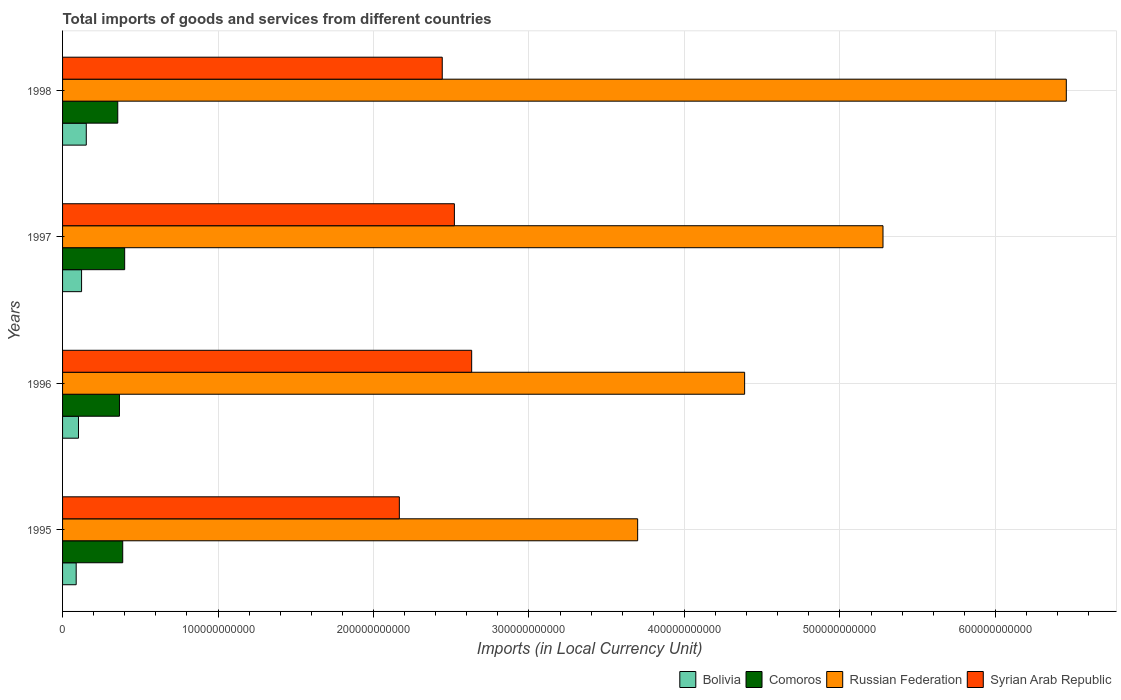Are the number of bars per tick equal to the number of legend labels?
Provide a short and direct response. Yes. How many bars are there on the 4th tick from the bottom?
Your answer should be very brief. 4. In how many cases, is the number of bars for a given year not equal to the number of legend labels?
Make the answer very short. 0. What is the Amount of goods and services imports in Russian Federation in 1995?
Offer a very short reply. 3.70e+11. Across all years, what is the maximum Amount of goods and services imports in Syrian Arab Republic?
Ensure brevity in your answer.  2.63e+11. Across all years, what is the minimum Amount of goods and services imports in Russian Federation?
Your answer should be compact. 3.70e+11. In which year was the Amount of goods and services imports in Comoros minimum?
Provide a short and direct response. 1998. What is the total Amount of goods and services imports in Russian Federation in the graph?
Your answer should be compact. 1.98e+12. What is the difference between the Amount of goods and services imports in Bolivia in 1995 and that in 1996?
Make the answer very short. -1.47e+09. What is the difference between the Amount of goods and services imports in Syrian Arab Republic in 1996 and the Amount of goods and services imports in Russian Federation in 1995?
Your answer should be very brief. -1.07e+11. What is the average Amount of goods and services imports in Russian Federation per year?
Make the answer very short. 4.95e+11. In the year 1998, what is the difference between the Amount of goods and services imports in Bolivia and Amount of goods and services imports in Syrian Arab Republic?
Your answer should be compact. -2.29e+11. In how many years, is the Amount of goods and services imports in Bolivia greater than 300000000000 LCU?
Your response must be concise. 0. What is the ratio of the Amount of goods and services imports in Syrian Arab Republic in 1995 to that in 1997?
Give a very brief answer. 0.86. Is the Amount of goods and services imports in Comoros in 1996 less than that in 1998?
Your response must be concise. No. What is the difference between the highest and the second highest Amount of goods and services imports in Russian Federation?
Provide a short and direct response. 1.18e+11. What is the difference between the highest and the lowest Amount of goods and services imports in Syrian Arab Republic?
Provide a succinct answer. 4.65e+1. What does the 2nd bar from the top in 1997 represents?
Your answer should be compact. Russian Federation. What does the 4th bar from the bottom in 1995 represents?
Offer a very short reply. Syrian Arab Republic. Is it the case that in every year, the sum of the Amount of goods and services imports in Russian Federation and Amount of goods and services imports in Comoros is greater than the Amount of goods and services imports in Bolivia?
Ensure brevity in your answer.  Yes. Are all the bars in the graph horizontal?
Provide a succinct answer. Yes. How many years are there in the graph?
Provide a succinct answer. 4. What is the difference between two consecutive major ticks on the X-axis?
Your answer should be compact. 1.00e+11. Are the values on the major ticks of X-axis written in scientific E-notation?
Provide a short and direct response. No. Where does the legend appear in the graph?
Offer a very short reply. Bottom right. How are the legend labels stacked?
Ensure brevity in your answer.  Horizontal. What is the title of the graph?
Give a very brief answer. Total imports of goods and services from different countries. Does "Kyrgyz Republic" appear as one of the legend labels in the graph?
Make the answer very short. No. What is the label or title of the X-axis?
Provide a succinct answer. Imports (in Local Currency Unit). What is the Imports (in Local Currency Unit) of Bolivia in 1995?
Give a very brief answer. 8.76e+09. What is the Imports (in Local Currency Unit) in Comoros in 1995?
Give a very brief answer. 3.87e+1. What is the Imports (in Local Currency Unit) in Russian Federation in 1995?
Your answer should be very brief. 3.70e+11. What is the Imports (in Local Currency Unit) in Syrian Arab Republic in 1995?
Offer a terse response. 2.17e+11. What is the Imports (in Local Currency Unit) of Bolivia in 1996?
Offer a terse response. 1.02e+1. What is the Imports (in Local Currency Unit) of Comoros in 1996?
Offer a very short reply. 3.66e+1. What is the Imports (in Local Currency Unit) of Russian Federation in 1996?
Make the answer very short. 4.39e+11. What is the Imports (in Local Currency Unit) of Syrian Arab Republic in 1996?
Ensure brevity in your answer.  2.63e+11. What is the Imports (in Local Currency Unit) of Bolivia in 1997?
Your answer should be compact. 1.22e+1. What is the Imports (in Local Currency Unit) of Comoros in 1997?
Offer a terse response. 3.99e+1. What is the Imports (in Local Currency Unit) of Russian Federation in 1997?
Ensure brevity in your answer.  5.28e+11. What is the Imports (in Local Currency Unit) in Syrian Arab Republic in 1997?
Your answer should be compact. 2.52e+11. What is the Imports (in Local Currency Unit) of Bolivia in 1998?
Make the answer very short. 1.53e+1. What is the Imports (in Local Currency Unit) in Comoros in 1998?
Your response must be concise. 3.55e+1. What is the Imports (in Local Currency Unit) of Russian Federation in 1998?
Ensure brevity in your answer.  6.46e+11. What is the Imports (in Local Currency Unit) in Syrian Arab Republic in 1998?
Give a very brief answer. 2.44e+11. Across all years, what is the maximum Imports (in Local Currency Unit) in Bolivia?
Make the answer very short. 1.53e+1. Across all years, what is the maximum Imports (in Local Currency Unit) of Comoros?
Give a very brief answer. 3.99e+1. Across all years, what is the maximum Imports (in Local Currency Unit) in Russian Federation?
Your response must be concise. 6.46e+11. Across all years, what is the maximum Imports (in Local Currency Unit) in Syrian Arab Republic?
Give a very brief answer. 2.63e+11. Across all years, what is the minimum Imports (in Local Currency Unit) of Bolivia?
Your answer should be very brief. 8.76e+09. Across all years, what is the minimum Imports (in Local Currency Unit) in Comoros?
Your answer should be very brief. 3.55e+1. Across all years, what is the minimum Imports (in Local Currency Unit) of Russian Federation?
Your response must be concise. 3.70e+11. Across all years, what is the minimum Imports (in Local Currency Unit) in Syrian Arab Republic?
Make the answer very short. 2.17e+11. What is the total Imports (in Local Currency Unit) in Bolivia in the graph?
Provide a short and direct response. 4.65e+1. What is the total Imports (in Local Currency Unit) in Comoros in the graph?
Provide a succinct answer. 1.51e+11. What is the total Imports (in Local Currency Unit) of Russian Federation in the graph?
Ensure brevity in your answer.  1.98e+12. What is the total Imports (in Local Currency Unit) of Syrian Arab Republic in the graph?
Give a very brief answer. 9.76e+11. What is the difference between the Imports (in Local Currency Unit) in Bolivia in 1995 and that in 1996?
Ensure brevity in your answer.  -1.47e+09. What is the difference between the Imports (in Local Currency Unit) in Comoros in 1995 and that in 1996?
Offer a terse response. 2.10e+09. What is the difference between the Imports (in Local Currency Unit) of Russian Federation in 1995 and that in 1996?
Ensure brevity in your answer.  -6.88e+1. What is the difference between the Imports (in Local Currency Unit) of Syrian Arab Republic in 1995 and that in 1996?
Provide a short and direct response. -4.65e+1. What is the difference between the Imports (in Local Currency Unit) of Bolivia in 1995 and that in 1997?
Offer a terse response. -3.46e+09. What is the difference between the Imports (in Local Currency Unit) of Comoros in 1995 and that in 1997?
Your response must be concise. -1.26e+09. What is the difference between the Imports (in Local Currency Unit) of Russian Federation in 1995 and that in 1997?
Keep it short and to the point. -1.58e+11. What is the difference between the Imports (in Local Currency Unit) in Syrian Arab Republic in 1995 and that in 1997?
Your answer should be very brief. -3.54e+1. What is the difference between the Imports (in Local Currency Unit) in Bolivia in 1995 and that in 1998?
Keep it short and to the point. -6.49e+09. What is the difference between the Imports (in Local Currency Unit) in Comoros in 1995 and that in 1998?
Offer a terse response. 3.18e+09. What is the difference between the Imports (in Local Currency Unit) of Russian Federation in 1995 and that in 1998?
Offer a terse response. -2.76e+11. What is the difference between the Imports (in Local Currency Unit) of Syrian Arab Republic in 1995 and that in 1998?
Offer a terse response. -2.76e+1. What is the difference between the Imports (in Local Currency Unit) in Bolivia in 1996 and that in 1997?
Keep it short and to the point. -1.99e+09. What is the difference between the Imports (in Local Currency Unit) of Comoros in 1996 and that in 1997?
Keep it short and to the point. -3.35e+09. What is the difference between the Imports (in Local Currency Unit) of Russian Federation in 1996 and that in 1997?
Your answer should be compact. -8.90e+1. What is the difference between the Imports (in Local Currency Unit) in Syrian Arab Republic in 1996 and that in 1997?
Ensure brevity in your answer.  1.11e+1. What is the difference between the Imports (in Local Currency Unit) in Bolivia in 1996 and that in 1998?
Your answer should be compact. -5.02e+09. What is the difference between the Imports (in Local Currency Unit) of Comoros in 1996 and that in 1998?
Your answer should be very brief. 1.09e+09. What is the difference between the Imports (in Local Currency Unit) of Russian Federation in 1996 and that in 1998?
Ensure brevity in your answer.  -2.07e+11. What is the difference between the Imports (in Local Currency Unit) in Syrian Arab Republic in 1996 and that in 1998?
Your answer should be very brief. 1.89e+1. What is the difference between the Imports (in Local Currency Unit) of Bolivia in 1997 and that in 1998?
Offer a very short reply. -3.03e+09. What is the difference between the Imports (in Local Currency Unit) in Comoros in 1997 and that in 1998?
Your answer should be very brief. 4.44e+09. What is the difference between the Imports (in Local Currency Unit) in Russian Federation in 1997 and that in 1998?
Your response must be concise. -1.18e+11. What is the difference between the Imports (in Local Currency Unit) in Syrian Arab Republic in 1997 and that in 1998?
Give a very brief answer. 7.81e+09. What is the difference between the Imports (in Local Currency Unit) of Bolivia in 1995 and the Imports (in Local Currency Unit) of Comoros in 1996?
Give a very brief answer. -2.78e+1. What is the difference between the Imports (in Local Currency Unit) of Bolivia in 1995 and the Imports (in Local Currency Unit) of Russian Federation in 1996?
Provide a succinct answer. -4.30e+11. What is the difference between the Imports (in Local Currency Unit) of Bolivia in 1995 and the Imports (in Local Currency Unit) of Syrian Arab Republic in 1996?
Your answer should be compact. -2.54e+11. What is the difference between the Imports (in Local Currency Unit) of Comoros in 1995 and the Imports (in Local Currency Unit) of Russian Federation in 1996?
Ensure brevity in your answer.  -4.00e+11. What is the difference between the Imports (in Local Currency Unit) of Comoros in 1995 and the Imports (in Local Currency Unit) of Syrian Arab Republic in 1996?
Provide a succinct answer. -2.24e+11. What is the difference between the Imports (in Local Currency Unit) in Russian Federation in 1995 and the Imports (in Local Currency Unit) in Syrian Arab Republic in 1996?
Offer a very short reply. 1.07e+11. What is the difference between the Imports (in Local Currency Unit) of Bolivia in 1995 and the Imports (in Local Currency Unit) of Comoros in 1997?
Offer a very short reply. -3.12e+1. What is the difference between the Imports (in Local Currency Unit) of Bolivia in 1995 and the Imports (in Local Currency Unit) of Russian Federation in 1997?
Offer a terse response. -5.19e+11. What is the difference between the Imports (in Local Currency Unit) in Bolivia in 1995 and the Imports (in Local Currency Unit) in Syrian Arab Republic in 1997?
Offer a terse response. -2.43e+11. What is the difference between the Imports (in Local Currency Unit) in Comoros in 1995 and the Imports (in Local Currency Unit) in Russian Federation in 1997?
Give a very brief answer. -4.89e+11. What is the difference between the Imports (in Local Currency Unit) in Comoros in 1995 and the Imports (in Local Currency Unit) in Syrian Arab Republic in 1997?
Your response must be concise. -2.13e+11. What is the difference between the Imports (in Local Currency Unit) of Russian Federation in 1995 and the Imports (in Local Currency Unit) of Syrian Arab Republic in 1997?
Keep it short and to the point. 1.18e+11. What is the difference between the Imports (in Local Currency Unit) of Bolivia in 1995 and the Imports (in Local Currency Unit) of Comoros in 1998?
Give a very brief answer. -2.67e+1. What is the difference between the Imports (in Local Currency Unit) in Bolivia in 1995 and the Imports (in Local Currency Unit) in Russian Federation in 1998?
Provide a short and direct response. -6.37e+11. What is the difference between the Imports (in Local Currency Unit) in Bolivia in 1995 and the Imports (in Local Currency Unit) in Syrian Arab Republic in 1998?
Your answer should be compact. -2.35e+11. What is the difference between the Imports (in Local Currency Unit) of Comoros in 1995 and the Imports (in Local Currency Unit) of Russian Federation in 1998?
Give a very brief answer. -6.07e+11. What is the difference between the Imports (in Local Currency Unit) in Comoros in 1995 and the Imports (in Local Currency Unit) in Syrian Arab Republic in 1998?
Your answer should be very brief. -2.06e+11. What is the difference between the Imports (in Local Currency Unit) in Russian Federation in 1995 and the Imports (in Local Currency Unit) in Syrian Arab Republic in 1998?
Ensure brevity in your answer.  1.26e+11. What is the difference between the Imports (in Local Currency Unit) of Bolivia in 1996 and the Imports (in Local Currency Unit) of Comoros in 1997?
Provide a succinct answer. -2.97e+1. What is the difference between the Imports (in Local Currency Unit) in Bolivia in 1996 and the Imports (in Local Currency Unit) in Russian Federation in 1997?
Your answer should be compact. -5.17e+11. What is the difference between the Imports (in Local Currency Unit) of Bolivia in 1996 and the Imports (in Local Currency Unit) of Syrian Arab Republic in 1997?
Your response must be concise. -2.42e+11. What is the difference between the Imports (in Local Currency Unit) of Comoros in 1996 and the Imports (in Local Currency Unit) of Russian Federation in 1997?
Provide a succinct answer. -4.91e+11. What is the difference between the Imports (in Local Currency Unit) in Comoros in 1996 and the Imports (in Local Currency Unit) in Syrian Arab Republic in 1997?
Give a very brief answer. -2.15e+11. What is the difference between the Imports (in Local Currency Unit) of Russian Federation in 1996 and the Imports (in Local Currency Unit) of Syrian Arab Republic in 1997?
Offer a very short reply. 1.87e+11. What is the difference between the Imports (in Local Currency Unit) of Bolivia in 1996 and the Imports (in Local Currency Unit) of Comoros in 1998?
Offer a terse response. -2.53e+1. What is the difference between the Imports (in Local Currency Unit) in Bolivia in 1996 and the Imports (in Local Currency Unit) in Russian Federation in 1998?
Ensure brevity in your answer.  -6.35e+11. What is the difference between the Imports (in Local Currency Unit) of Bolivia in 1996 and the Imports (in Local Currency Unit) of Syrian Arab Republic in 1998?
Offer a terse response. -2.34e+11. What is the difference between the Imports (in Local Currency Unit) in Comoros in 1996 and the Imports (in Local Currency Unit) in Russian Federation in 1998?
Provide a succinct answer. -6.09e+11. What is the difference between the Imports (in Local Currency Unit) in Comoros in 1996 and the Imports (in Local Currency Unit) in Syrian Arab Republic in 1998?
Offer a very short reply. -2.08e+11. What is the difference between the Imports (in Local Currency Unit) in Russian Federation in 1996 and the Imports (in Local Currency Unit) in Syrian Arab Republic in 1998?
Provide a short and direct response. 1.94e+11. What is the difference between the Imports (in Local Currency Unit) of Bolivia in 1997 and the Imports (in Local Currency Unit) of Comoros in 1998?
Provide a succinct answer. -2.33e+1. What is the difference between the Imports (in Local Currency Unit) in Bolivia in 1997 and the Imports (in Local Currency Unit) in Russian Federation in 1998?
Offer a very short reply. -6.33e+11. What is the difference between the Imports (in Local Currency Unit) in Bolivia in 1997 and the Imports (in Local Currency Unit) in Syrian Arab Republic in 1998?
Provide a short and direct response. -2.32e+11. What is the difference between the Imports (in Local Currency Unit) of Comoros in 1997 and the Imports (in Local Currency Unit) of Russian Federation in 1998?
Keep it short and to the point. -6.06e+11. What is the difference between the Imports (in Local Currency Unit) of Comoros in 1997 and the Imports (in Local Currency Unit) of Syrian Arab Republic in 1998?
Your response must be concise. -2.04e+11. What is the difference between the Imports (in Local Currency Unit) in Russian Federation in 1997 and the Imports (in Local Currency Unit) in Syrian Arab Republic in 1998?
Offer a very short reply. 2.83e+11. What is the average Imports (in Local Currency Unit) of Bolivia per year?
Offer a very short reply. 1.16e+1. What is the average Imports (in Local Currency Unit) in Comoros per year?
Keep it short and to the point. 3.77e+1. What is the average Imports (in Local Currency Unit) of Russian Federation per year?
Your answer should be compact. 4.95e+11. What is the average Imports (in Local Currency Unit) in Syrian Arab Republic per year?
Provide a short and direct response. 2.44e+11. In the year 1995, what is the difference between the Imports (in Local Currency Unit) of Bolivia and Imports (in Local Currency Unit) of Comoros?
Give a very brief answer. -2.99e+1. In the year 1995, what is the difference between the Imports (in Local Currency Unit) in Bolivia and Imports (in Local Currency Unit) in Russian Federation?
Give a very brief answer. -3.61e+11. In the year 1995, what is the difference between the Imports (in Local Currency Unit) in Bolivia and Imports (in Local Currency Unit) in Syrian Arab Republic?
Your answer should be very brief. -2.08e+11. In the year 1995, what is the difference between the Imports (in Local Currency Unit) in Comoros and Imports (in Local Currency Unit) in Russian Federation?
Your response must be concise. -3.31e+11. In the year 1995, what is the difference between the Imports (in Local Currency Unit) of Comoros and Imports (in Local Currency Unit) of Syrian Arab Republic?
Make the answer very short. -1.78e+11. In the year 1995, what is the difference between the Imports (in Local Currency Unit) of Russian Federation and Imports (in Local Currency Unit) of Syrian Arab Republic?
Offer a very short reply. 1.53e+11. In the year 1996, what is the difference between the Imports (in Local Currency Unit) in Bolivia and Imports (in Local Currency Unit) in Comoros?
Keep it short and to the point. -2.64e+1. In the year 1996, what is the difference between the Imports (in Local Currency Unit) of Bolivia and Imports (in Local Currency Unit) of Russian Federation?
Your answer should be very brief. -4.28e+11. In the year 1996, what is the difference between the Imports (in Local Currency Unit) of Bolivia and Imports (in Local Currency Unit) of Syrian Arab Republic?
Provide a short and direct response. -2.53e+11. In the year 1996, what is the difference between the Imports (in Local Currency Unit) of Comoros and Imports (in Local Currency Unit) of Russian Federation?
Your response must be concise. -4.02e+11. In the year 1996, what is the difference between the Imports (in Local Currency Unit) in Comoros and Imports (in Local Currency Unit) in Syrian Arab Republic?
Ensure brevity in your answer.  -2.27e+11. In the year 1996, what is the difference between the Imports (in Local Currency Unit) in Russian Federation and Imports (in Local Currency Unit) in Syrian Arab Republic?
Offer a very short reply. 1.76e+11. In the year 1997, what is the difference between the Imports (in Local Currency Unit) of Bolivia and Imports (in Local Currency Unit) of Comoros?
Keep it short and to the point. -2.77e+1. In the year 1997, what is the difference between the Imports (in Local Currency Unit) of Bolivia and Imports (in Local Currency Unit) of Russian Federation?
Your answer should be very brief. -5.15e+11. In the year 1997, what is the difference between the Imports (in Local Currency Unit) of Bolivia and Imports (in Local Currency Unit) of Syrian Arab Republic?
Provide a succinct answer. -2.40e+11. In the year 1997, what is the difference between the Imports (in Local Currency Unit) of Comoros and Imports (in Local Currency Unit) of Russian Federation?
Provide a succinct answer. -4.88e+11. In the year 1997, what is the difference between the Imports (in Local Currency Unit) of Comoros and Imports (in Local Currency Unit) of Syrian Arab Republic?
Give a very brief answer. -2.12e+11. In the year 1997, what is the difference between the Imports (in Local Currency Unit) of Russian Federation and Imports (in Local Currency Unit) of Syrian Arab Republic?
Your answer should be compact. 2.76e+11. In the year 1998, what is the difference between the Imports (in Local Currency Unit) in Bolivia and Imports (in Local Currency Unit) in Comoros?
Your answer should be compact. -2.03e+1. In the year 1998, what is the difference between the Imports (in Local Currency Unit) of Bolivia and Imports (in Local Currency Unit) of Russian Federation?
Your answer should be compact. -6.30e+11. In the year 1998, what is the difference between the Imports (in Local Currency Unit) of Bolivia and Imports (in Local Currency Unit) of Syrian Arab Republic?
Provide a succinct answer. -2.29e+11. In the year 1998, what is the difference between the Imports (in Local Currency Unit) in Comoros and Imports (in Local Currency Unit) in Russian Federation?
Your response must be concise. -6.10e+11. In the year 1998, what is the difference between the Imports (in Local Currency Unit) of Comoros and Imports (in Local Currency Unit) of Syrian Arab Republic?
Offer a very short reply. -2.09e+11. In the year 1998, what is the difference between the Imports (in Local Currency Unit) of Russian Federation and Imports (in Local Currency Unit) of Syrian Arab Republic?
Make the answer very short. 4.01e+11. What is the ratio of the Imports (in Local Currency Unit) of Bolivia in 1995 to that in 1996?
Provide a short and direct response. 0.86. What is the ratio of the Imports (in Local Currency Unit) in Comoros in 1995 to that in 1996?
Ensure brevity in your answer.  1.06. What is the ratio of the Imports (in Local Currency Unit) of Russian Federation in 1995 to that in 1996?
Your response must be concise. 0.84. What is the ratio of the Imports (in Local Currency Unit) in Syrian Arab Republic in 1995 to that in 1996?
Ensure brevity in your answer.  0.82. What is the ratio of the Imports (in Local Currency Unit) of Bolivia in 1995 to that in 1997?
Offer a very short reply. 0.72. What is the ratio of the Imports (in Local Currency Unit) in Comoros in 1995 to that in 1997?
Offer a very short reply. 0.97. What is the ratio of the Imports (in Local Currency Unit) of Russian Federation in 1995 to that in 1997?
Offer a very short reply. 0.7. What is the ratio of the Imports (in Local Currency Unit) of Syrian Arab Republic in 1995 to that in 1997?
Offer a terse response. 0.86. What is the ratio of the Imports (in Local Currency Unit) in Bolivia in 1995 to that in 1998?
Offer a terse response. 0.57. What is the ratio of the Imports (in Local Currency Unit) of Comoros in 1995 to that in 1998?
Provide a short and direct response. 1.09. What is the ratio of the Imports (in Local Currency Unit) in Russian Federation in 1995 to that in 1998?
Your response must be concise. 0.57. What is the ratio of the Imports (in Local Currency Unit) of Syrian Arab Republic in 1995 to that in 1998?
Offer a very short reply. 0.89. What is the ratio of the Imports (in Local Currency Unit) of Bolivia in 1996 to that in 1997?
Ensure brevity in your answer.  0.84. What is the ratio of the Imports (in Local Currency Unit) of Comoros in 1996 to that in 1997?
Make the answer very short. 0.92. What is the ratio of the Imports (in Local Currency Unit) of Russian Federation in 1996 to that in 1997?
Provide a short and direct response. 0.83. What is the ratio of the Imports (in Local Currency Unit) in Syrian Arab Republic in 1996 to that in 1997?
Your answer should be compact. 1.04. What is the ratio of the Imports (in Local Currency Unit) in Bolivia in 1996 to that in 1998?
Offer a very short reply. 0.67. What is the ratio of the Imports (in Local Currency Unit) of Comoros in 1996 to that in 1998?
Give a very brief answer. 1.03. What is the ratio of the Imports (in Local Currency Unit) in Russian Federation in 1996 to that in 1998?
Ensure brevity in your answer.  0.68. What is the ratio of the Imports (in Local Currency Unit) in Syrian Arab Republic in 1996 to that in 1998?
Provide a short and direct response. 1.08. What is the ratio of the Imports (in Local Currency Unit) in Bolivia in 1997 to that in 1998?
Your answer should be compact. 0.8. What is the ratio of the Imports (in Local Currency Unit) in Russian Federation in 1997 to that in 1998?
Your answer should be very brief. 0.82. What is the ratio of the Imports (in Local Currency Unit) in Syrian Arab Republic in 1997 to that in 1998?
Give a very brief answer. 1.03. What is the difference between the highest and the second highest Imports (in Local Currency Unit) of Bolivia?
Provide a succinct answer. 3.03e+09. What is the difference between the highest and the second highest Imports (in Local Currency Unit) in Comoros?
Offer a very short reply. 1.26e+09. What is the difference between the highest and the second highest Imports (in Local Currency Unit) in Russian Federation?
Keep it short and to the point. 1.18e+11. What is the difference between the highest and the second highest Imports (in Local Currency Unit) of Syrian Arab Republic?
Your answer should be very brief. 1.11e+1. What is the difference between the highest and the lowest Imports (in Local Currency Unit) in Bolivia?
Your answer should be compact. 6.49e+09. What is the difference between the highest and the lowest Imports (in Local Currency Unit) of Comoros?
Make the answer very short. 4.44e+09. What is the difference between the highest and the lowest Imports (in Local Currency Unit) in Russian Federation?
Make the answer very short. 2.76e+11. What is the difference between the highest and the lowest Imports (in Local Currency Unit) in Syrian Arab Republic?
Provide a succinct answer. 4.65e+1. 